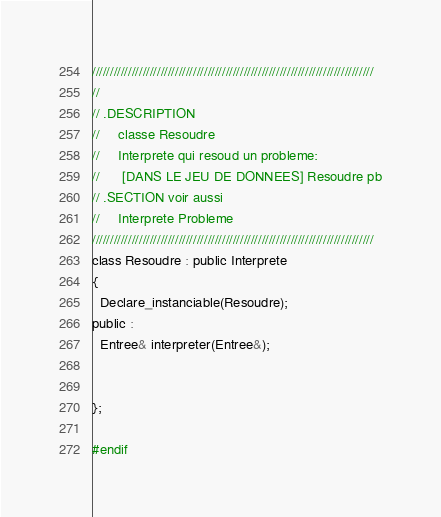<code> <loc_0><loc_0><loc_500><loc_500><_C_>//////////////////////////////////////////////////////////////////////////////
//
// .DESCRIPTION
//     classe Resoudre
//     Interprete qui resoud un probleme:
//      [DANS LE JEU DE DONNEES] Resoudre pb
// .SECTION voir aussi
//     Interprete Probleme
//////////////////////////////////////////////////////////////////////////////
class Resoudre : public Interprete
{
  Declare_instanciable(Resoudre);
public :
  Entree& interpreter(Entree&);


};

#endif
</code> 